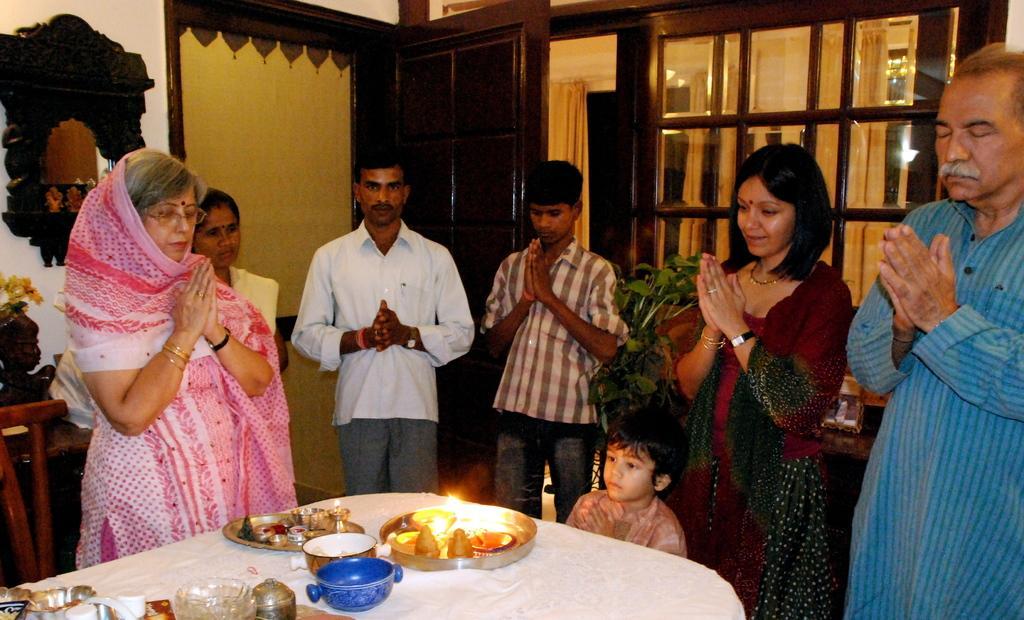Please provide a concise description of this image. In this picture we can see woman who is standing near to the table. On the table we can see plates, bowls, lamp, tissue papers and other objects. Beside the table there is a boy. On the right there is a man who is wearing blue dress, beside him we can see woman who is standing near to the plant. Near to the door there is a man who is wearing white shirt, watch and trouser. Beside him there is a boy. 